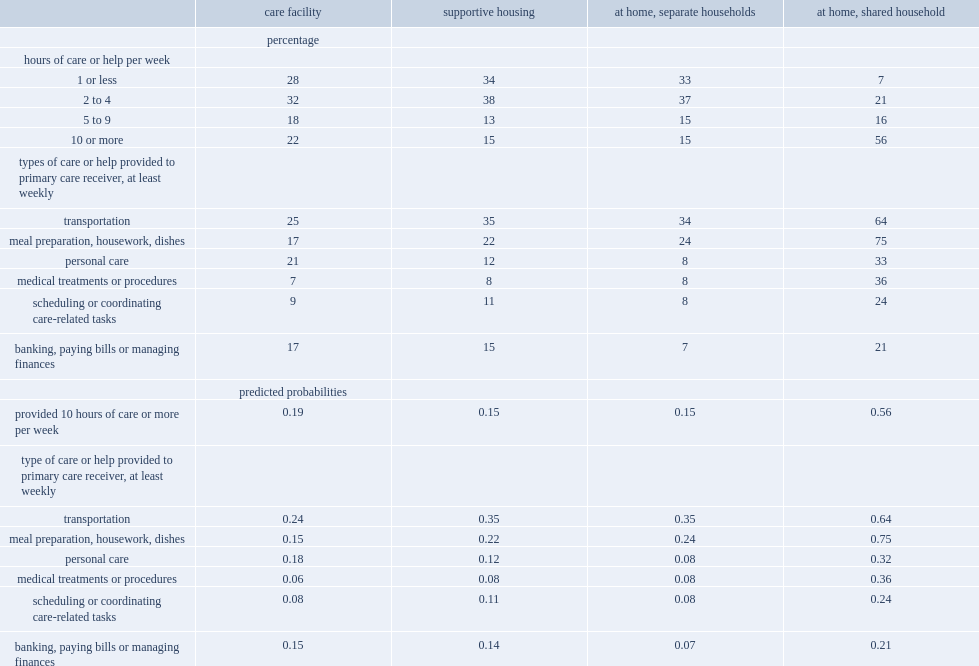How many percent of people provided at least 10 hours of care to their care receiver in a typical week? 56.0. How many percent of care facility provided 10 hours of care or more per week in 2012? 22.0. How many percent of people helping seniors in a separate household provided 10 hours of care or more per week in 2012? 15.0. How many percent of people helping seniors in supportive housing provided 10 hours of care or more per week in 2012? 15.0. Can you give me this table as a dict? {'header': ['', 'care facility', 'supportive housing', 'at home, separate households', 'at home, shared household'], 'rows': [['', 'percentage', '', '', ''], ['hours of care or help per week', '', '', '', ''], ['1 or less', '28', '34', '33', '7'], ['2 to 4', '32', '38', '37', '21'], ['5 to 9', '18', '13', '15', '16'], ['10 or more', '22', '15', '15', '56'], ['types of care or help provided to primary care receiver, at least weekly', '', '', '', ''], ['transportation', '25', '35', '34', '64'], ['meal preparation, housework, dishes', '17', '22', '24', '75'], ['personal care', '21', '12', '8', '33'], ['medical treatments or procedures', '7', '8', '8', '36'], ['scheduling or coordinating care-related tasks', '9', '11', '8', '24'], ['banking, paying bills or managing finances', '17', '15', '7', '21'], ['', 'predicted probabilities', '', '', ''], ['provided 10 hours of care or more per week', '0.19', '0.15', '0.15', '0.56'], ['type of care or help provided to primary care receiver, at least weekly', '', '', '', ''], ['transportation', '0.24', '0.35', '0.35', '0.64'], ['meal preparation, housework, dishes', '0.15', '0.22', '0.24', '0.75'], ['personal care', '0.18', '0.12', '0.08', '0.32'], ['medical treatments or procedures', '0.06', '0.08', '0.08', '0.36'], ['scheduling or coordinating care-related tasks', '0.08', '0.11', '0.08', '0.24'], ['banking, paying bills or managing finances', '0.15', '0.14', '0.07', '0.21']]} 